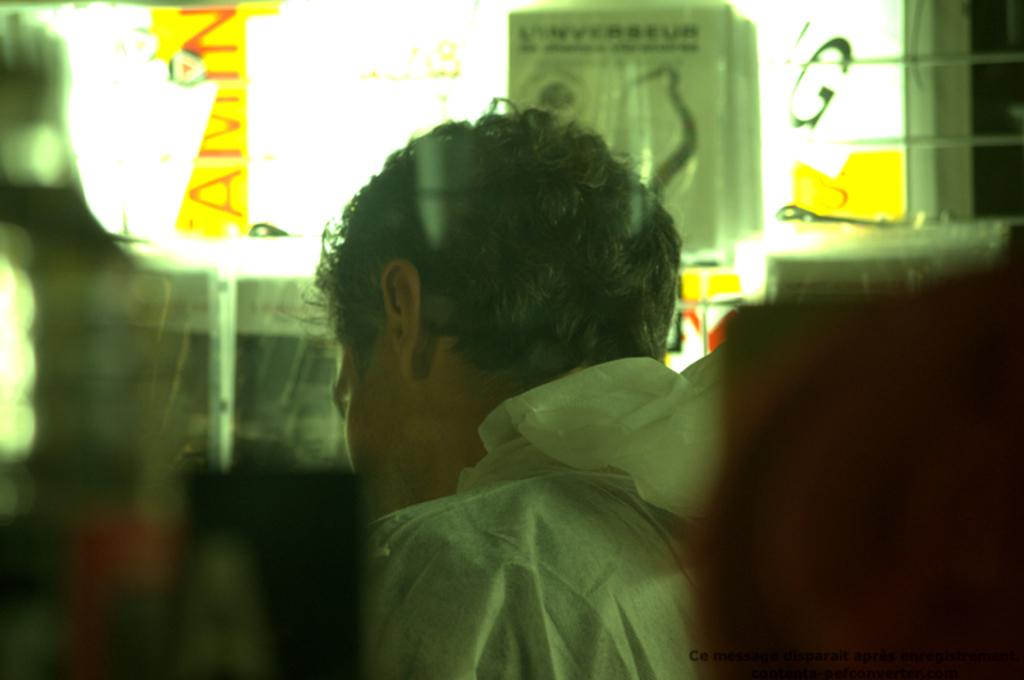What is the main subject of the image? There is a person in the image. What direction is the person facing? The person is facing towards the back. What other objects can be seen in the image? There are papers with text in the image. Where are the papers located in the image? The papers are at the top of the image. What type of swing can be seen in the image? There is no swing present in the image. How does the person use the tub in the image? There is no tub present in the image. 